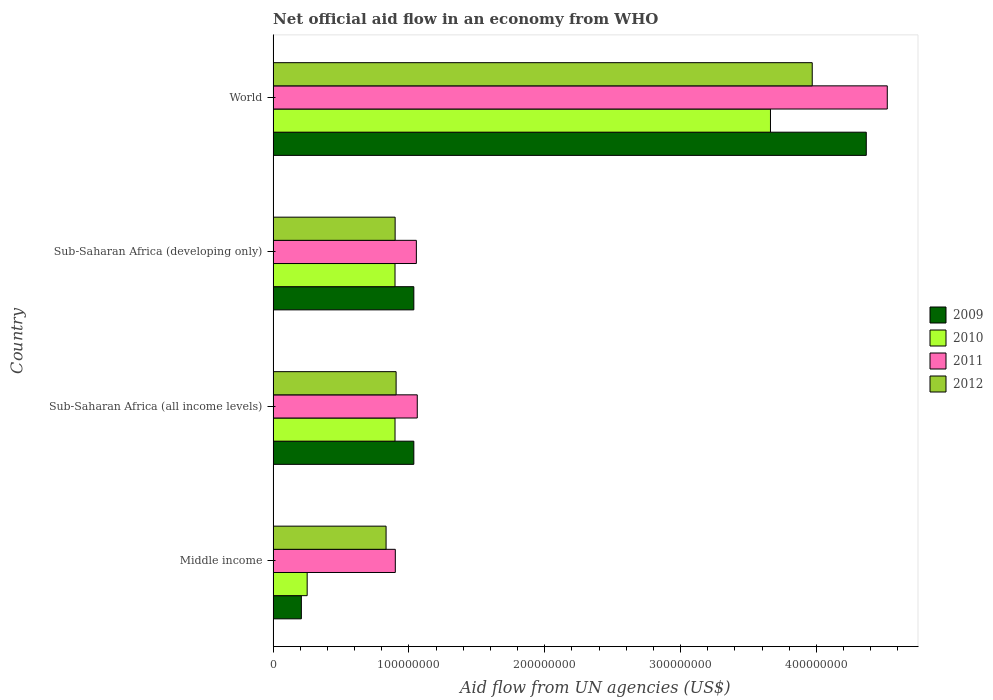How many different coloured bars are there?
Provide a short and direct response. 4. How many groups of bars are there?
Provide a short and direct response. 4. Are the number of bars on each tick of the Y-axis equal?
Offer a very short reply. Yes. How many bars are there on the 1st tick from the top?
Give a very brief answer. 4. In how many cases, is the number of bars for a given country not equal to the number of legend labels?
Your answer should be compact. 0. What is the net official aid flow in 2009 in Middle income?
Make the answer very short. 2.08e+07. Across all countries, what is the maximum net official aid flow in 2011?
Make the answer very short. 4.52e+08. Across all countries, what is the minimum net official aid flow in 2011?
Your answer should be compact. 9.00e+07. What is the total net official aid flow in 2012 in the graph?
Keep it short and to the point. 6.61e+08. What is the difference between the net official aid flow in 2011 in Middle income and that in Sub-Saharan Africa (all income levels)?
Keep it short and to the point. -1.62e+07. What is the difference between the net official aid flow in 2009 in Sub-Saharan Africa (all income levels) and the net official aid flow in 2012 in Sub-Saharan Africa (developing only)?
Give a very brief answer. 1.38e+07. What is the average net official aid flow in 2011 per country?
Your answer should be very brief. 1.88e+08. What is the difference between the net official aid flow in 2012 and net official aid flow in 2011 in Sub-Saharan Africa (developing only)?
Make the answer very short. -1.56e+07. In how many countries, is the net official aid flow in 2012 greater than 20000000 US$?
Ensure brevity in your answer.  4. What is the ratio of the net official aid flow in 2010 in Middle income to that in World?
Ensure brevity in your answer.  0.07. What is the difference between the highest and the second highest net official aid flow in 2009?
Ensure brevity in your answer.  3.33e+08. What is the difference between the highest and the lowest net official aid flow in 2012?
Offer a terse response. 3.14e+08. Is the sum of the net official aid flow in 2011 in Sub-Saharan Africa (developing only) and World greater than the maximum net official aid flow in 2010 across all countries?
Ensure brevity in your answer.  Yes. Is it the case that in every country, the sum of the net official aid flow in 2012 and net official aid flow in 2011 is greater than the net official aid flow in 2009?
Make the answer very short. Yes. What is the difference between two consecutive major ticks on the X-axis?
Ensure brevity in your answer.  1.00e+08. Are the values on the major ticks of X-axis written in scientific E-notation?
Your response must be concise. No. Where does the legend appear in the graph?
Keep it short and to the point. Center right. How are the legend labels stacked?
Make the answer very short. Vertical. What is the title of the graph?
Provide a short and direct response. Net official aid flow in an economy from WHO. Does "2004" appear as one of the legend labels in the graph?
Offer a terse response. No. What is the label or title of the X-axis?
Your response must be concise. Aid flow from UN agencies (US$). What is the label or title of the Y-axis?
Give a very brief answer. Country. What is the Aid flow from UN agencies (US$) in 2009 in Middle income?
Your response must be concise. 2.08e+07. What is the Aid flow from UN agencies (US$) of 2010 in Middle income?
Give a very brief answer. 2.51e+07. What is the Aid flow from UN agencies (US$) in 2011 in Middle income?
Provide a short and direct response. 9.00e+07. What is the Aid flow from UN agencies (US$) of 2012 in Middle income?
Your answer should be compact. 8.32e+07. What is the Aid flow from UN agencies (US$) of 2009 in Sub-Saharan Africa (all income levels)?
Your answer should be very brief. 1.04e+08. What is the Aid flow from UN agencies (US$) of 2010 in Sub-Saharan Africa (all income levels)?
Offer a terse response. 8.98e+07. What is the Aid flow from UN agencies (US$) of 2011 in Sub-Saharan Africa (all income levels)?
Offer a very short reply. 1.06e+08. What is the Aid flow from UN agencies (US$) of 2012 in Sub-Saharan Africa (all income levels)?
Give a very brief answer. 9.06e+07. What is the Aid flow from UN agencies (US$) in 2009 in Sub-Saharan Africa (developing only)?
Your answer should be very brief. 1.04e+08. What is the Aid flow from UN agencies (US$) in 2010 in Sub-Saharan Africa (developing only)?
Make the answer very short. 8.98e+07. What is the Aid flow from UN agencies (US$) of 2011 in Sub-Saharan Africa (developing only)?
Offer a terse response. 1.05e+08. What is the Aid flow from UN agencies (US$) in 2012 in Sub-Saharan Africa (developing only)?
Provide a short and direct response. 8.98e+07. What is the Aid flow from UN agencies (US$) in 2009 in World?
Your answer should be compact. 4.37e+08. What is the Aid flow from UN agencies (US$) of 2010 in World?
Keep it short and to the point. 3.66e+08. What is the Aid flow from UN agencies (US$) of 2011 in World?
Your answer should be compact. 4.52e+08. What is the Aid flow from UN agencies (US$) in 2012 in World?
Provide a succinct answer. 3.97e+08. Across all countries, what is the maximum Aid flow from UN agencies (US$) in 2009?
Keep it short and to the point. 4.37e+08. Across all countries, what is the maximum Aid flow from UN agencies (US$) of 2010?
Keep it short and to the point. 3.66e+08. Across all countries, what is the maximum Aid flow from UN agencies (US$) of 2011?
Offer a very short reply. 4.52e+08. Across all countries, what is the maximum Aid flow from UN agencies (US$) of 2012?
Offer a terse response. 3.97e+08. Across all countries, what is the minimum Aid flow from UN agencies (US$) of 2009?
Give a very brief answer. 2.08e+07. Across all countries, what is the minimum Aid flow from UN agencies (US$) of 2010?
Offer a terse response. 2.51e+07. Across all countries, what is the minimum Aid flow from UN agencies (US$) in 2011?
Provide a short and direct response. 9.00e+07. Across all countries, what is the minimum Aid flow from UN agencies (US$) in 2012?
Keep it short and to the point. 8.32e+07. What is the total Aid flow from UN agencies (US$) of 2009 in the graph?
Give a very brief answer. 6.65e+08. What is the total Aid flow from UN agencies (US$) of 2010 in the graph?
Make the answer very short. 5.71e+08. What is the total Aid flow from UN agencies (US$) in 2011 in the graph?
Offer a terse response. 7.54e+08. What is the total Aid flow from UN agencies (US$) of 2012 in the graph?
Make the answer very short. 6.61e+08. What is the difference between the Aid flow from UN agencies (US$) in 2009 in Middle income and that in Sub-Saharan Africa (all income levels)?
Make the answer very short. -8.28e+07. What is the difference between the Aid flow from UN agencies (US$) in 2010 in Middle income and that in Sub-Saharan Africa (all income levels)?
Your answer should be compact. -6.47e+07. What is the difference between the Aid flow from UN agencies (US$) of 2011 in Middle income and that in Sub-Saharan Africa (all income levels)?
Ensure brevity in your answer.  -1.62e+07. What is the difference between the Aid flow from UN agencies (US$) of 2012 in Middle income and that in Sub-Saharan Africa (all income levels)?
Your answer should be compact. -7.39e+06. What is the difference between the Aid flow from UN agencies (US$) of 2009 in Middle income and that in Sub-Saharan Africa (developing only)?
Keep it short and to the point. -8.28e+07. What is the difference between the Aid flow from UN agencies (US$) of 2010 in Middle income and that in Sub-Saharan Africa (developing only)?
Offer a very short reply. -6.47e+07. What is the difference between the Aid flow from UN agencies (US$) of 2011 in Middle income and that in Sub-Saharan Africa (developing only)?
Provide a succinct answer. -1.55e+07. What is the difference between the Aid flow from UN agencies (US$) of 2012 in Middle income and that in Sub-Saharan Africa (developing only)?
Offer a terse response. -6.67e+06. What is the difference between the Aid flow from UN agencies (US$) of 2009 in Middle income and that in World?
Your answer should be very brief. -4.16e+08. What is the difference between the Aid flow from UN agencies (US$) in 2010 in Middle income and that in World?
Give a very brief answer. -3.41e+08. What is the difference between the Aid flow from UN agencies (US$) in 2011 in Middle income and that in World?
Make the answer very short. -3.62e+08. What is the difference between the Aid flow from UN agencies (US$) of 2012 in Middle income and that in World?
Give a very brief answer. -3.14e+08. What is the difference between the Aid flow from UN agencies (US$) of 2009 in Sub-Saharan Africa (all income levels) and that in Sub-Saharan Africa (developing only)?
Provide a succinct answer. 0. What is the difference between the Aid flow from UN agencies (US$) in 2010 in Sub-Saharan Africa (all income levels) and that in Sub-Saharan Africa (developing only)?
Give a very brief answer. 0. What is the difference between the Aid flow from UN agencies (US$) in 2011 in Sub-Saharan Africa (all income levels) and that in Sub-Saharan Africa (developing only)?
Your response must be concise. 6.70e+05. What is the difference between the Aid flow from UN agencies (US$) of 2012 in Sub-Saharan Africa (all income levels) and that in Sub-Saharan Africa (developing only)?
Your answer should be very brief. 7.20e+05. What is the difference between the Aid flow from UN agencies (US$) in 2009 in Sub-Saharan Africa (all income levels) and that in World?
Keep it short and to the point. -3.33e+08. What is the difference between the Aid flow from UN agencies (US$) in 2010 in Sub-Saharan Africa (all income levels) and that in World?
Offer a terse response. -2.76e+08. What is the difference between the Aid flow from UN agencies (US$) in 2011 in Sub-Saharan Africa (all income levels) and that in World?
Ensure brevity in your answer.  -3.46e+08. What is the difference between the Aid flow from UN agencies (US$) in 2012 in Sub-Saharan Africa (all income levels) and that in World?
Keep it short and to the point. -3.06e+08. What is the difference between the Aid flow from UN agencies (US$) of 2009 in Sub-Saharan Africa (developing only) and that in World?
Your answer should be compact. -3.33e+08. What is the difference between the Aid flow from UN agencies (US$) in 2010 in Sub-Saharan Africa (developing only) and that in World?
Make the answer very short. -2.76e+08. What is the difference between the Aid flow from UN agencies (US$) of 2011 in Sub-Saharan Africa (developing only) and that in World?
Your answer should be very brief. -3.47e+08. What is the difference between the Aid flow from UN agencies (US$) of 2012 in Sub-Saharan Africa (developing only) and that in World?
Your response must be concise. -3.07e+08. What is the difference between the Aid flow from UN agencies (US$) in 2009 in Middle income and the Aid flow from UN agencies (US$) in 2010 in Sub-Saharan Africa (all income levels)?
Your answer should be compact. -6.90e+07. What is the difference between the Aid flow from UN agencies (US$) in 2009 in Middle income and the Aid flow from UN agencies (US$) in 2011 in Sub-Saharan Africa (all income levels)?
Offer a terse response. -8.54e+07. What is the difference between the Aid flow from UN agencies (US$) of 2009 in Middle income and the Aid flow from UN agencies (US$) of 2012 in Sub-Saharan Africa (all income levels)?
Offer a very short reply. -6.98e+07. What is the difference between the Aid flow from UN agencies (US$) in 2010 in Middle income and the Aid flow from UN agencies (US$) in 2011 in Sub-Saharan Africa (all income levels)?
Your answer should be compact. -8.11e+07. What is the difference between the Aid flow from UN agencies (US$) in 2010 in Middle income and the Aid flow from UN agencies (US$) in 2012 in Sub-Saharan Africa (all income levels)?
Provide a succinct answer. -6.55e+07. What is the difference between the Aid flow from UN agencies (US$) in 2011 in Middle income and the Aid flow from UN agencies (US$) in 2012 in Sub-Saharan Africa (all income levels)?
Give a very brief answer. -5.90e+05. What is the difference between the Aid flow from UN agencies (US$) of 2009 in Middle income and the Aid flow from UN agencies (US$) of 2010 in Sub-Saharan Africa (developing only)?
Your answer should be compact. -6.90e+07. What is the difference between the Aid flow from UN agencies (US$) in 2009 in Middle income and the Aid flow from UN agencies (US$) in 2011 in Sub-Saharan Africa (developing only)?
Your response must be concise. -8.47e+07. What is the difference between the Aid flow from UN agencies (US$) of 2009 in Middle income and the Aid flow from UN agencies (US$) of 2012 in Sub-Saharan Africa (developing only)?
Provide a succinct answer. -6.90e+07. What is the difference between the Aid flow from UN agencies (US$) of 2010 in Middle income and the Aid flow from UN agencies (US$) of 2011 in Sub-Saharan Africa (developing only)?
Ensure brevity in your answer.  -8.04e+07. What is the difference between the Aid flow from UN agencies (US$) in 2010 in Middle income and the Aid flow from UN agencies (US$) in 2012 in Sub-Saharan Africa (developing only)?
Your response must be concise. -6.48e+07. What is the difference between the Aid flow from UN agencies (US$) of 2009 in Middle income and the Aid flow from UN agencies (US$) of 2010 in World?
Make the answer very short. -3.45e+08. What is the difference between the Aid flow from UN agencies (US$) in 2009 in Middle income and the Aid flow from UN agencies (US$) in 2011 in World?
Ensure brevity in your answer.  -4.31e+08. What is the difference between the Aid flow from UN agencies (US$) in 2009 in Middle income and the Aid flow from UN agencies (US$) in 2012 in World?
Ensure brevity in your answer.  -3.76e+08. What is the difference between the Aid flow from UN agencies (US$) of 2010 in Middle income and the Aid flow from UN agencies (US$) of 2011 in World?
Provide a succinct answer. -4.27e+08. What is the difference between the Aid flow from UN agencies (US$) of 2010 in Middle income and the Aid flow from UN agencies (US$) of 2012 in World?
Your answer should be very brief. -3.72e+08. What is the difference between the Aid flow from UN agencies (US$) of 2011 in Middle income and the Aid flow from UN agencies (US$) of 2012 in World?
Your answer should be compact. -3.07e+08. What is the difference between the Aid flow from UN agencies (US$) of 2009 in Sub-Saharan Africa (all income levels) and the Aid flow from UN agencies (US$) of 2010 in Sub-Saharan Africa (developing only)?
Ensure brevity in your answer.  1.39e+07. What is the difference between the Aid flow from UN agencies (US$) of 2009 in Sub-Saharan Africa (all income levels) and the Aid flow from UN agencies (US$) of 2011 in Sub-Saharan Africa (developing only)?
Give a very brief answer. -1.86e+06. What is the difference between the Aid flow from UN agencies (US$) of 2009 in Sub-Saharan Africa (all income levels) and the Aid flow from UN agencies (US$) of 2012 in Sub-Saharan Africa (developing only)?
Offer a very short reply. 1.38e+07. What is the difference between the Aid flow from UN agencies (US$) in 2010 in Sub-Saharan Africa (all income levels) and the Aid flow from UN agencies (US$) in 2011 in Sub-Saharan Africa (developing only)?
Provide a succinct answer. -1.57e+07. What is the difference between the Aid flow from UN agencies (US$) of 2011 in Sub-Saharan Africa (all income levels) and the Aid flow from UN agencies (US$) of 2012 in Sub-Saharan Africa (developing only)?
Provide a short and direct response. 1.63e+07. What is the difference between the Aid flow from UN agencies (US$) in 2009 in Sub-Saharan Africa (all income levels) and the Aid flow from UN agencies (US$) in 2010 in World?
Ensure brevity in your answer.  -2.63e+08. What is the difference between the Aid flow from UN agencies (US$) of 2009 in Sub-Saharan Africa (all income levels) and the Aid flow from UN agencies (US$) of 2011 in World?
Keep it short and to the point. -3.49e+08. What is the difference between the Aid flow from UN agencies (US$) of 2009 in Sub-Saharan Africa (all income levels) and the Aid flow from UN agencies (US$) of 2012 in World?
Your answer should be compact. -2.93e+08. What is the difference between the Aid flow from UN agencies (US$) in 2010 in Sub-Saharan Africa (all income levels) and the Aid flow from UN agencies (US$) in 2011 in World?
Provide a short and direct response. -3.62e+08. What is the difference between the Aid flow from UN agencies (US$) in 2010 in Sub-Saharan Africa (all income levels) and the Aid flow from UN agencies (US$) in 2012 in World?
Your answer should be compact. -3.07e+08. What is the difference between the Aid flow from UN agencies (US$) in 2011 in Sub-Saharan Africa (all income levels) and the Aid flow from UN agencies (US$) in 2012 in World?
Your response must be concise. -2.91e+08. What is the difference between the Aid flow from UN agencies (US$) of 2009 in Sub-Saharan Africa (developing only) and the Aid flow from UN agencies (US$) of 2010 in World?
Your answer should be compact. -2.63e+08. What is the difference between the Aid flow from UN agencies (US$) of 2009 in Sub-Saharan Africa (developing only) and the Aid flow from UN agencies (US$) of 2011 in World?
Your response must be concise. -3.49e+08. What is the difference between the Aid flow from UN agencies (US$) of 2009 in Sub-Saharan Africa (developing only) and the Aid flow from UN agencies (US$) of 2012 in World?
Offer a terse response. -2.93e+08. What is the difference between the Aid flow from UN agencies (US$) in 2010 in Sub-Saharan Africa (developing only) and the Aid flow from UN agencies (US$) in 2011 in World?
Provide a short and direct response. -3.62e+08. What is the difference between the Aid flow from UN agencies (US$) of 2010 in Sub-Saharan Africa (developing only) and the Aid flow from UN agencies (US$) of 2012 in World?
Offer a terse response. -3.07e+08. What is the difference between the Aid flow from UN agencies (US$) in 2011 in Sub-Saharan Africa (developing only) and the Aid flow from UN agencies (US$) in 2012 in World?
Your response must be concise. -2.92e+08. What is the average Aid flow from UN agencies (US$) in 2009 per country?
Make the answer very short. 1.66e+08. What is the average Aid flow from UN agencies (US$) in 2010 per country?
Ensure brevity in your answer.  1.43e+08. What is the average Aid flow from UN agencies (US$) in 2011 per country?
Provide a short and direct response. 1.88e+08. What is the average Aid flow from UN agencies (US$) in 2012 per country?
Provide a short and direct response. 1.65e+08. What is the difference between the Aid flow from UN agencies (US$) of 2009 and Aid flow from UN agencies (US$) of 2010 in Middle income?
Offer a terse response. -4.27e+06. What is the difference between the Aid flow from UN agencies (US$) of 2009 and Aid flow from UN agencies (US$) of 2011 in Middle income?
Give a very brief answer. -6.92e+07. What is the difference between the Aid flow from UN agencies (US$) of 2009 and Aid flow from UN agencies (US$) of 2012 in Middle income?
Keep it short and to the point. -6.24e+07. What is the difference between the Aid flow from UN agencies (US$) of 2010 and Aid flow from UN agencies (US$) of 2011 in Middle income?
Provide a short and direct response. -6.49e+07. What is the difference between the Aid flow from UN agencies (US$) of 2010 and Aid flow from UN agencies (US$) of 2012 in Middle income?
Provide a succinct answer. -5.81e+07. What is the difference between the Aid flow from UN agencies (US$) in 2011 and Aid flow from UN agencies (US$) in 2012 in Middle income?
Make the answer very short. 6.80e+06. What is the difference between the Aid flow from UN agencies (US$) in 2009 and Aid flow from UN agencies (US$) in 2010 in Sub-Saharan Africa (all income levels)?
Offer a terse response. 1.39e+07. What is the difference between the Aid flow from UN agencies (US$) of 2009 and Aid flow from UN agencies (US$) of 2011 in Sub-Saharan Africa (all income levels)?
Offer a very short reply. -2.53e+06. What is the difference between the Aid flow from UN agencies (US$) in 2009 and Aid flow from UN agencies (US$) in 2012 in Sub-Saharan Africa (all income levels)?
Offer a very short reply. 1.30e+07. What is the difference between the Aid flow from UN agencies (US$) of 2010 and Aid flow from UN agencies (US$) of 2011 in Sub-Saharan Africa (all income levels)?
Provide a short and direct response. -1.64e+07. What is the difference between the Aid flow from UN agencies (US$) in 2010 and Aid flow from UN agencies (US$) in 2012 in Sub-Saharan Africa (all income levels)?
Offer a very short reply. -8.10e+05. What is the difference between the Aid flow from UN agencies (US$) in 2011 and Aid flow from UN agencies (US$) in 2012 in Sub-Saharan Africa (all income levels)?
Provide a short and direct response. 1.56e+07. What is the difference between the Aid flow from UN agencies (US$) of 2009 and Aid flow from UN agencies (US$) of 2010 in Sub-Saharan Africa (developing only)?
Your answer should be very brief. 1.39e+07. What is the difference between the Aid flow from UN agencies (US$) in 2009 and Aid flow from UN agencies (US$) in 2011 in Sub-Saharan Africa (developing only)?
Ensure brevity in your answer.  -1.86e+06. What is the difference between the Aid flow from UN agencies (US$) of 2009 and Aid flow from UN agencies (US$) of 2012 in Sub-Saharan Africa (developing only)?
Provide a succinct answer. 1.38e+07. What is the difference between the Aid flow from UN agencies (US$) of 2010 and Aid flow from UN agencies (US$) of 2011 in Sub-Saharan Africa (developing only)?
Your answer should be very brief. -1.57e+07. What is the difference between the Aid flow from UN agencies (US$) of 2010 and Aid flow from UN agencies (US$) of 2012 in Sub-Saharan Africa (developing only)?
Make the answer very short. -9.00e+04. What is the difference between the Aid flow from UN agencies (US$) in 2011 and Aid flow from UN agencies (US$) in 2012 in Sub-Saharan Africa (developing only)?
Offer a very short reply. 1.56e+07. What is the difference between the Aid flow from UN agencies (US$) in 2009 and Aid flow from UN agencies (US$) in 2010 in World?
Your response must be concise. 7.06e+07. What is the difference between the Aid flow from UN agencies (US$) in 2009 and Aid flow from UN agencies (US$) in 2011 in World?
Your answer should be compact. -1.55e+07. What is the difference between the Aid flow from UN agencies (US$) of 2009 and Aid flow from UN agencies (US$) of 2012 in World?
Provide a succinct answer. 3.98e+07. What is the difference between the Aid flow from UN agencies (US$) in 2010 and Aid flow from UN agencies (US$) in 2011 in World?
Your answer should be compact. -8.60e+07. What is the difference between the Aid flow from UN agencies (US$) of 2010 and Aid flow from UN agencies (US$) of 2012 in World?
Keep it short and to the point. -3.08e+07. What is the difference between the Aid flow from UN agencies (US$) in 2011 and Aid flow from UN agencies (US$) in 2012 in World?
Keep it short and to the point. 5.53e+07. What is the ratio of the Aid flow from UN agencies (US$) in 2009 in Middle income to that in Sub-Saharan Africa (all income levels)?
Provide a succinct answer. 0.2. What is the ratio of the Aid flow from UN agencies (US$) of 2010 in Middle income to that in Sub-Saharan Africa (all income levels)?
Make the answer very short. 0.28. What is the ratio of the Aid flow from UN agencies (US$) in 2011 in Middle income to that in Sub-Saharan Africa (all income levels)?
Keep it short and to the point. 0.85. What is the ratio of the Aid flow from UN agencies (US$) of 2012 in Middle income to that in Sub-Saharan Africa (all income levels)?
Provide a succinct answer. 0.92. What is the ratio of the Aid flow from UN agencies (US$) of 2009 in Middle income to that in Sub-Saharan Africa (developing only)?
Make the answer very short. 0.2. What is the ratio of the Aid flow from UN agencies (US$) in 2010 in Middle income to that in Sub-Saharan Africa (developing only)?
Keep it short and to the point. 0.28. What is the ratio of the Aid flow from UN agencies (US$) in 2011 in Middle income to that in Sub-Saharan Africa (developing only)?
Offer a terse response. 0.85. What is the ratio of the Aid flow from UN agencies (US$) of 2012 in Middle income to that in Sub-Saharan Africa (developing only)?
Your answer should be very brief. 0.93. What is the ratio of the Aid flow from UN agencies (US$) of 2009 in Middle income to that in World?
Offer a terse response. 0.05. What is the ratio of the Aid flow from UN agencies (US$) of 2010 in Middle income to that in World?
Offer a terse response. 0.07. What is the ratio of the Aid flow from UN agencies (US$) of 2011 in Middle income to that in World?
Offer a very short reply. 0.2. What is the ratio of the Aid flow from UN agencies (US$) in 2012 in Middle income to that in World?
Provide a short and direct response. 0.21. What is the ratio of the Aid flow from UN agencies (US$) in 2011 in Sub-Saharan Africa (all income levels) to that in Sub-Saharan Africa (developing only)?
Your answer should be compact. 1.01. What is the ratio of the Aid flow from UN agencies (US$) of 2009 in Sub-Saharan Africa (all income levels) to that in World?
Provide a succinct answer. 0.24. What is the ratio of the Aid flow from UN agencies (US$) of 2010 in Sub-Saharan Africa (all income levels) to that in World?
Your answer should be very brief. 0.25. What is the ratio of the Aid flow from UN agencies (US$) of 2011 in Sub-Saharan Africa (all income levels) to that in World?
Your answer should be compact. 0.23. What is the ratio of the Aid flow from UN agencies (US$) in 2012 in Sub-Saharan Africa (all income levels) to that in World?
Keep it short and to the point. 0.23. What is the ratio of the Aid flow from UN agencies (US$) of 2009 in Sub-Saharan Africa (developing only) to that in World?
Offer a terse response. 0.24. What is the ratio of the Aid flow from UN agencies (US$) in 2010 in Sub-Saharan Africa (developing only) to that in World?
Provide a succinct answer. 0.25. What is the ratio of the Aid flow from UN agencies (US$) of 2011 in Sub-Saharan Africa (developing only) to that in World?
Offer a terse response. 0.23. What is the ratio of the Aid flow from UN agencies (US$) of 2012 in Sub-Saharan Africa (developing only) to that in World?
Offer a very short reply. 0.23. What is the difference between the highest and the second highest Aid flow from UN agencies (US$) in 2009?
Keep it short and to the point. 3.33e+08. What is the difference between the highest and the second highest Aid flow from UN agencies (US$) of 2010?
Keep it short and to the point. 2.76e+08. What is the difference between the highest and the second highest Aid flow from UN agencies (US$) of 2011?
Ensure brevity in your answer.  3.46e+08. What is the difference between the highest and the second highest Aid flow from UN agencies (US$) of 2012?
Offer a terse response. 3.06e+08. What is the difference between the highest and the lowest Aid flow from UN agencies (US$) in 2009?
Offer a terse response. 4.16e+08. What is the difference between the highest and the lowest Aid flow from UN agencies (US$) of 2010?
Your answer should be very brief. 3.41e+08. What is the difference between the highest and the lowest Aid flow from UN agencies (US$) of 2011?
Provide a succinct answer. 3.62e+08. What is the difference between the highest and the lowest Aid flow from UN agencies (US$) in 2012?
Your answer should be very brief. 3.14e+08. 